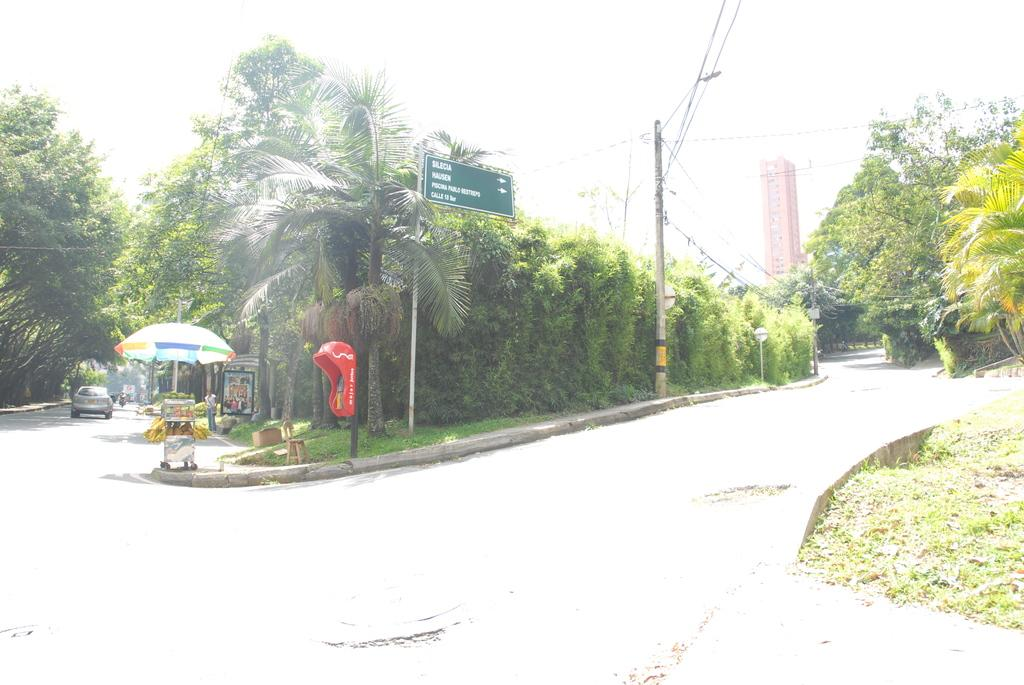What is the main object in the image? There is a sign board in the image. What else can be seen related to infrastructure in the image? Electric poles and a building are visible in the image. Are there any natural elements present in the image? Yes, trees and creepers are present in the image. What type of establishment might be represented by the stall under a parasol? It could be a small shop or vendor selling goods or services. Can you describe the presence of people in the image? A person is standing on the road in the image. What mode of transportation is visible in the image? Motor vehicles are visible in the image. What is visible in the sky in the image? The sky is visible in the image. What month is it in the image? The image does not provide any information about the month or time of year. What type of love is being expressed in the image? There is no indication of love or any emotional expression in the image. Can you describe the pickle being sold at the stall in the image? There is no pickle present in the image; the stall is not specified as selling pickles. 